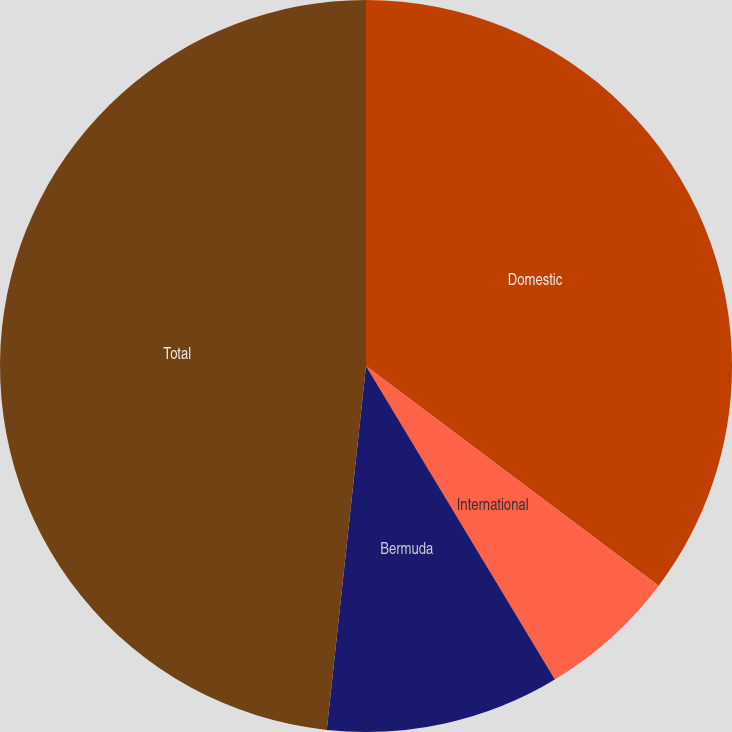Convert chart. <chart><loc_0><loc_0><loc_500><loc_500><pie_chart><fcel>Domestic<fcel>International<fcel>Bermuda<fcel>Total<nl><fcel>35.25%<fcel>6.12%<fcel>10.34%<fcel>48.29%<nl></chart> 